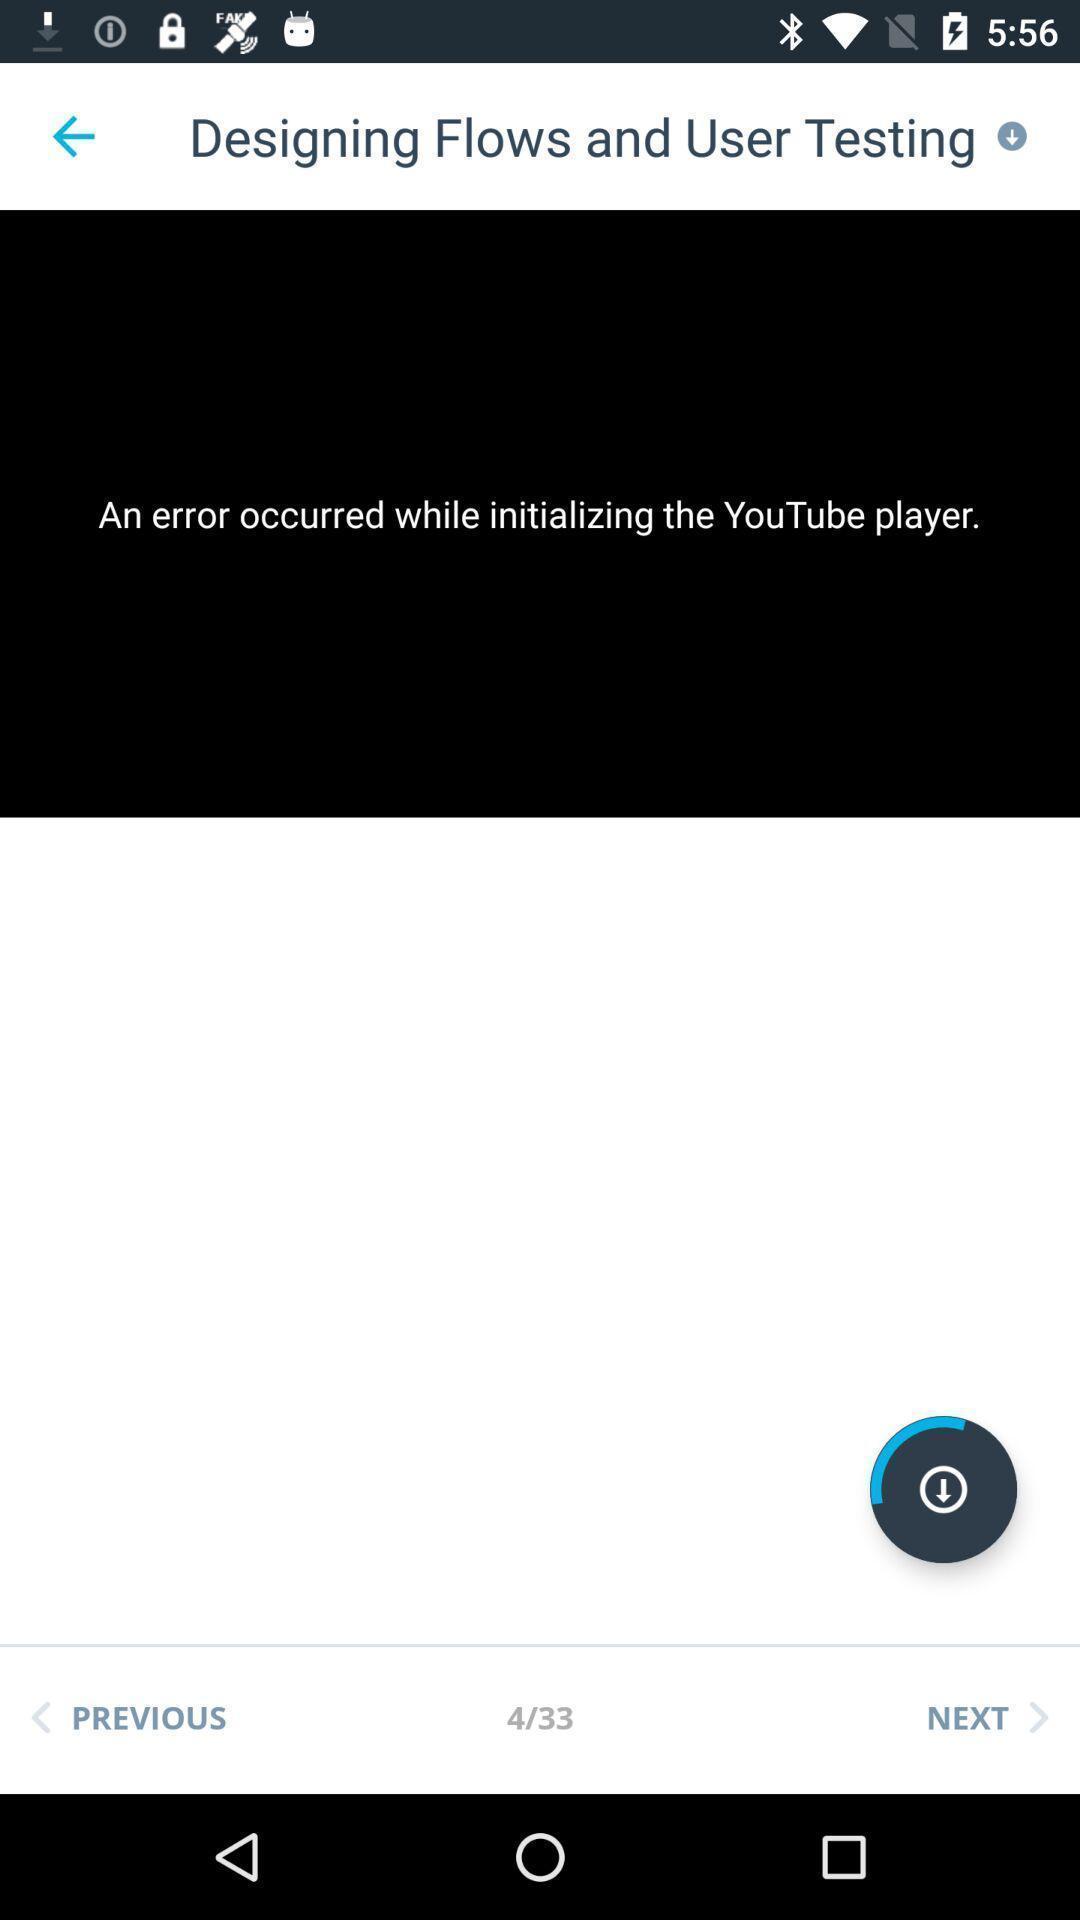Explain what's happening in this screen capture. Page showing error message in a video player app. 